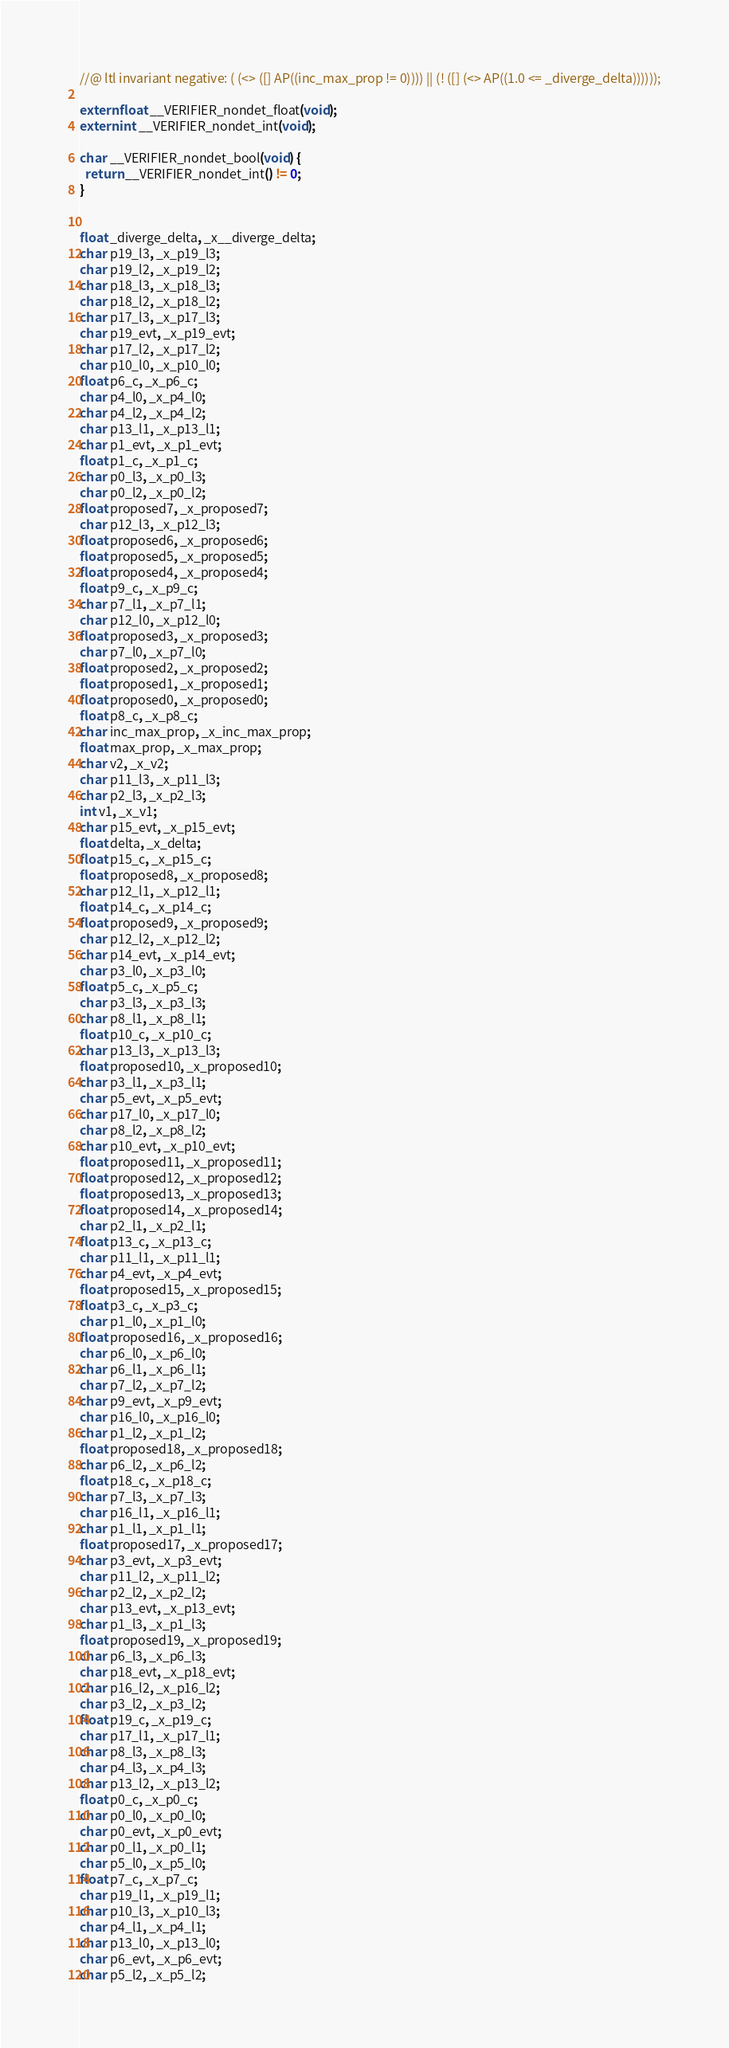Convert code to text. <code><loc_0><loc_0><loc_500><loc_500><_C_>//@ ltl invariant negative: ( (<> ([] AP((inc_max_prop != 0)))) || (! ([] (<> AP((1.0 <= _diverge_delta))))));

extern float __VERIFIER_nondet_float(void);
extern int __VERIFIER_nondet_int(void);

char __VERIFIER_nondet_bool(void) {
  return __VERIFIER_nondet_int() != 0;
}


float _diverge_delta, _x__diverge_delta;
char p19_l3, _x_p19_l3;
char p19_l2, _x_p19_l2;
char p18_l3, _x_p18_l3;
char p18_l2, _x_p18_l2;
char p17_l3, _x_p17_l3;
char p19_evt, _x_p19_evt;
char p17_l2, _x_p17_l2;
char p10_l0, _x_p10_l0;
float p6_c, _x_p6_c;
char p4_l0, _x_p4_l0;
char p4_l2, _x_p4_l2;
char p13_l1, _x_p13_l1;
char p1_evt, _x_p1_evt;
float p1_c, _x_p1_c;
char p0_l3, _x_p0_l3;
char p0_l2, _x_p0_l2;
float proposed7, _x_proposed7;
char p12_l3, _x_p12_l3;
float proposed6, _x_proposed6;
float proposed5, _x_proposed5;
float proposed4, _x_proposed4;
float p9_c, _x_p9_c;
char p7_l1, _x_p7_l1;
char p12_l0, _x_p12_l0;
float proposed3, _x_proposed3;
char p7_l0, _x_p7_l0;
float proposed2, _x_proposed2;
float proposed1, _x_proposed1;
float proposed0, _x_proposed0;
float p8_c, _x_p8_c;
char inc_max_prop, _x_inc_max_prop;
float max_prop, _x_max_prop;
char v2, _x_v2;
char p11_l3, _x_p11_l3;
char p2_l3, _x_p2_l3;
int v1, _x_v1;
char p15_evt, _x_p15_evt;
float delta, _x_delta;
float p15_c, _x_p15_c;
float proposed8, _x_proposed8;
char p12_l1, _x_p12_l1;
float p14_c, _x_p14_c;
float proposed9, _x_proposed9;
char p12_l2, _x_p12_l2;
char p14_evt, _x_p14_evt;
char p3_l0, _x_p3_l0;
float p5_c, _x_p5_c;
char p3_l3, _x_p3_l3;
char p8_l1, _x_p8_l1;
float p10_c, _x_p10_c;
char p13_l3, _x_p13_l3;
float proposed10, _x_proposed10;
char p3_l1, _x_p3_l1;
char p5_evt, _x_p5_evt;
char p17_l0, _x_p17_l0;
char p8_l2, _x_p8_l2;
char p10_evt, _x_p10_evt;
float proposed11, _x_proposed11;
float proposed12, _x_proposed12;
float proposed13, _x_proposed13;
float proposed14, _x_proposed14;
char p2_l1, _x_p2_l1;
float p13_c, _x_p13_c;
char p11_l1, _x_p11_l1;
char p4_evt, _x_p4_evt;
float proposed15, _x_proposed15;
float p3_c, _x_p3_c;
char p1_l0, _x_p1_l0;
float proposed16, _x_proposed16;
char p6_l0, _x_p6_l0;
char p6_l1, _x_p6_l1;
char p7_l2, _x_p7_l2;
char p9_evt, _x_p9_evt;
char p16_l0, _x_p16_l0;
char p1_l2, _x_p1_l2;
float proposed18, _x_proposed18;
char p6_l2, _x_p6_l2;
float p18_c, _x_p18_c;
char p7_l3, _x_p7_l3;
char p16_l1, _x_p16_l1;
char p1_l1, _x_p1_l1;
float proposed17, _x_proposed17;
char p3_evt, _x_p3_evt;
char p11_l2, _x_p11_l2;
char p2_l2, _x_p2_l2;
char p13_evt, _x_p13_evt;
char p1_l3, _x_p1_l3;
float proposed19, _x_proposed19;
char p6_l3, _x_p6_l3;
char p18_evt, _x_p18_evt;
char p16_l2, _x_p16_l2;
char p3_l2, _x_p3_l2;
float p19_c, _x_p19_c;
char p17_l1, _x_p17_l1;
char p8_l3, _x_p8_l3;
char p4_l3, _x_p4_l3;
char p13_l2, _x_p13_l2;
float p0_c, _x_p0_c;
char p0_l0, _x_p0_l0;
char p0_evt, _x_p0_evt;
char p0_l1, _x_p0_l1;
char p5_l0, _x_p5_l0;
float p7_c, _x_p7_c;
char p19_l1, _x_p19_l1;
char p10_l3, _x_p10_l3;
char p4_l1, _x_p4_l1;
char p13_l0, _x_p13_l0;
char p6_evt, _x_p6_evt;
char p5_l2, _x_p5_l2;</code> 